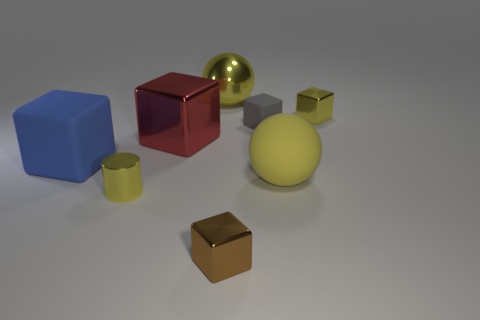Add 1 big rubber blocks. How many objects exist? 9 Subtract all blue rubber cubes. How many cubes are left? 4 Subtract all cylinders. How many objects are left? 7 Subtract all brown cubes. How many cubes are left? 4 Subtract 2 blocks. How many blocks are left? 3 Add 3 brown blocks. How many brown blocks are left? 4 Add 8 large red shiny objects. How many large red shiny objects exist? 9 Subtract 0 green spheres. How many objects are left? 8 Subtract all blue cylinders. Subtract all red spheres. How many cylinders are left? 1 Subtract all green balls. How many red blocks are left? 1 